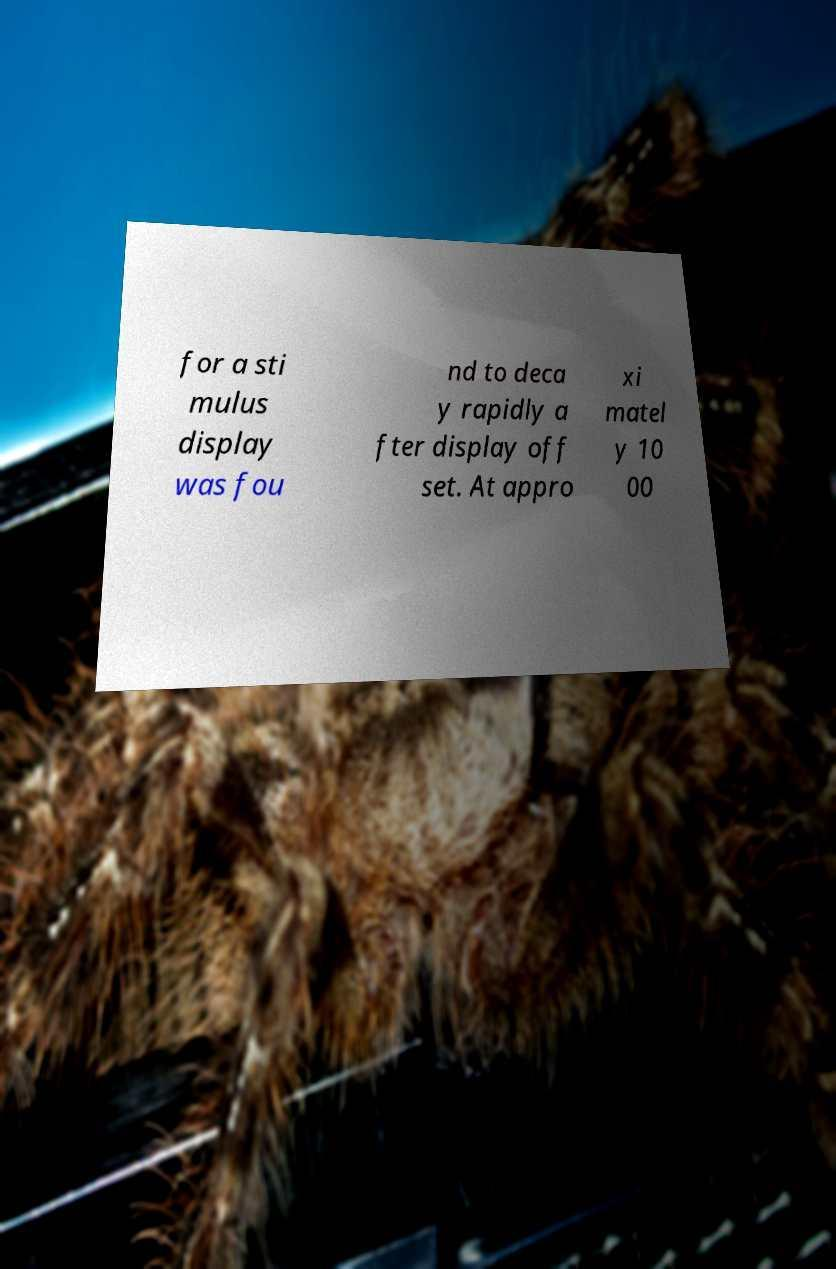Could you assist in decoding the text presented in this image and type it out clearly? for a sti mulus display was fou nd to deca y rapidly a fter display off set. At appro xi matel y 10 00 